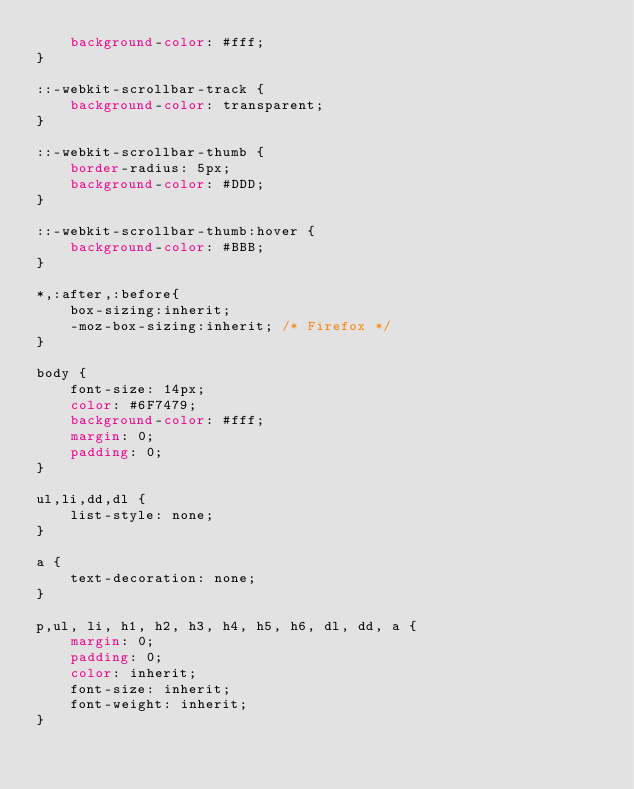<code> <loc_0><loc_0><loc_500><loc_500><_CSS_>    background-color: #fff;
}

::-webkit-scrollbar-track {
    background-color: transparent;
}

::-webkit-scrollbar-thumb {
    border-radius: 5px;
    background-color: #DDD;
}

::-webkit-scrollbar-thumb:hover {
    background-color: #BBB;
}

*,:after,:before{
    box-sizing:inherit;
    -moz-box-sizing:inherit; /* Firefox */
}

body {
    font-size: 14px;
    color: #6F7479;
    background-color: #fff;
    margin: 0;
    padding: 0;
}

ul,li,dd,dl {
    list-style: none;
}

a {
    text-decoration: none;
}

p,ul, li, h1, h2, h3, h4, h5, h6, dl, dd, a {
    margin: 0;
    padding: 0;
    color: inherit;
    font-size: inherit;
    font-weight: inherit;
}
</code> 